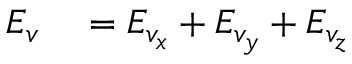Convert formula to latex. <formula><loc_0><loc_0><loc_500><loc_500>\begin{array} { r l } { E _ { v } } & = E _ { v _ { x } } + E _ { v _ { y } } + E _ { v _ { z } } } \end{array}</formula> 